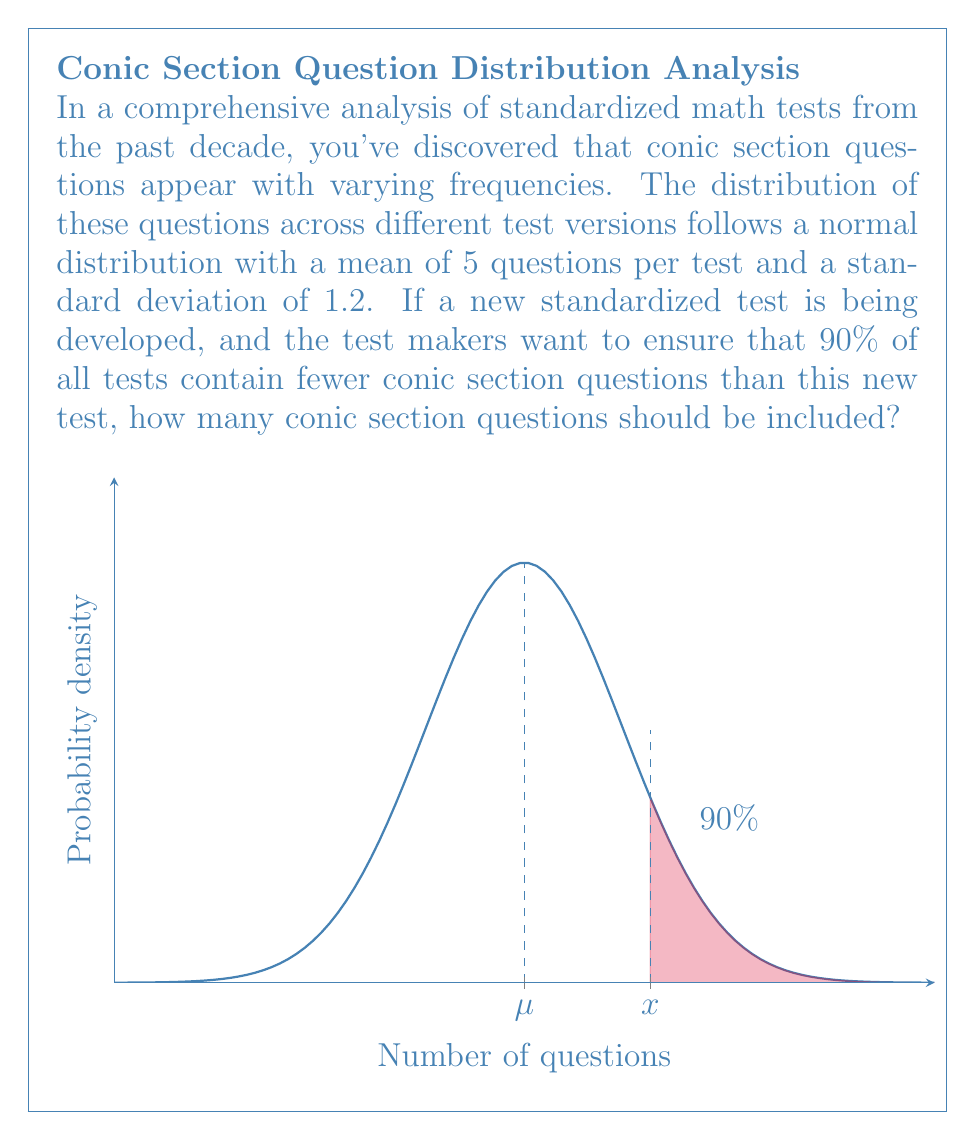Can you solve this math problem? To solve this problem, we need to use the properties of the normal distribution and the concept of z-scores. Let's break it down step-by-step:

1) We're given that the distribution is normal with:
   $\mu = 5$ (mean)
   $\sigma = 1.2$ (standard deviation)

2) We need to find the number of questions (x) that corresponds to the 90th percentile. This means that 90% of the tests should have fewer questions than x.

3) In a normal distribution, we can use the z-score to find this value. The z-score for the 90th percentile is approximately 1.28 (from standard normal distribution tables).

4) The formula for z-score is:
   $z = \frac{x - \mu}{\sigma}$

5) We can rearrange this to solve for x:
   $x = \mu + z\sigma$

6) Plugging in our values:
   $x = 5 + (1.28 * 1.2)$
   $x = 5 + 1.536$
   $x = 6.536$

7) Since we can't have a fractional number of questions, we need to round up to the nearest whole number.

8) Therefore, the new test should include 7 conic section questions to ensure that 90% of all tests contain fewer questions.
Answer: 7 questions 